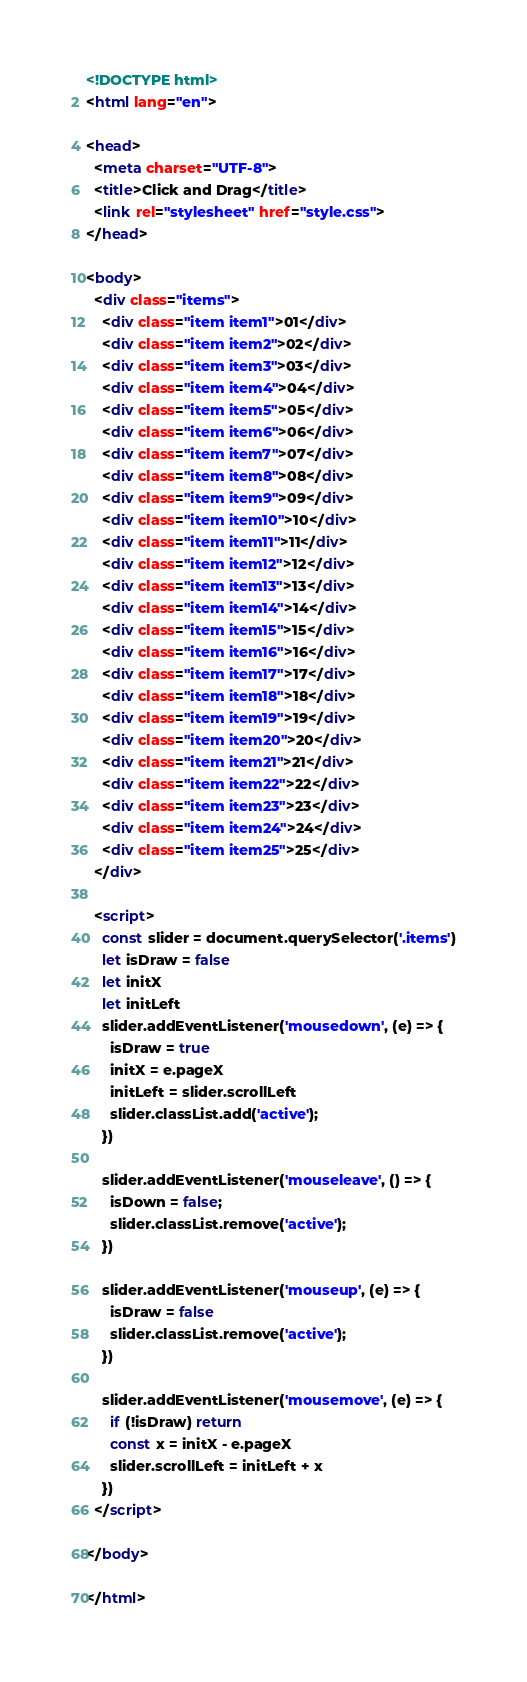Convert code to text. <code><loc_0><loc_0><loc_500><loc_500><_HTML_><!DOCTYPE html>
<html lang="en">

<head>
  <meta charset="UTF-8">
  <title>Click and Drag</title>
  <link rel="stylesheet" href="style.css">
</head>

<body>
  <div class="items">
    <div class="item item1">01</div>
    <div class="item item2">02</div>
    <div class="item item3">03</div>
    <div class="item item4">04</div>
    <div class="item item5">05</div>
    <div class="item item6">06</div>
    <div class="item item7">07</div>
    <div class="item item8">08</div>
    <div class="item item9">09</div>
    <div class="item item10">10</div>
    <div class="item item11">11</div>
    <div class="item item12">12</div>
    <div class="item item13">13</div>
    <div class="item item14">14</div>
    <div class="item item15">15</div>
    <div class="item item16">16</div>
    <div class="item item17">17</div>
    <div class="item item18">18</div>
    <div class="item item19">19</div>
    <div class="item item20">20</div>
    <div class="item item21">21</div>
    <div class="item item22">22</div>
    <div class="item item23">23</div>
    <div class="item item24">24</div>
    <div class="item item25">25</div>
  </div>

  <script>
    const slider = document.querySelector('.items')
    let isDraw = false
    let initX
    let initLeft
    slider.addEventListener('mousedown', (e) => {
      isDraw = true
      initX = e.pageX
      initLeft = slider.scrollLeft
      slider.classList.add('active');
    })

    slider.addEventListener('mouseleave', () => {
      isDown = false;
      slider.classList.remove('active');
    })

    slider.addEventListener('mouseup', (e) => {
      isDraw = false
      slider.classList.remove('active');
    })

    slider.addEventListener('mousemove', (e) => {
      if (!isDraw) return
      const x = initX - e.pageX
      slider.scrollLeft = initLeft + x
    })
  </script>

</body>

</html></code> 